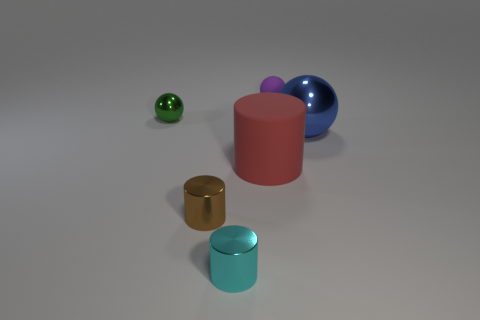Subtract all tiny balls. How many balls are left? 1 Subtract 1 spheres. How many spheres are left? 2 Add 4 large gray metallic objects. How many objects exist? 10 Subtract all blue blocks. How many purple cylinders are left? 0 Subtract all purple things. Subtract all tiny things. How many objects are left? 1 Add 3 purple matte things. How many purple matte things are left? 4 Add 6 big blue metallic things. How many big blue metallic things exist? 7 Subtract all purple balls. How many balls are left? 2 Subtract 0 purple cylinders. How many objects are left? 6 Subtract all blue cylinders. Subtract all green spheres. How many cylinders are left? 3 